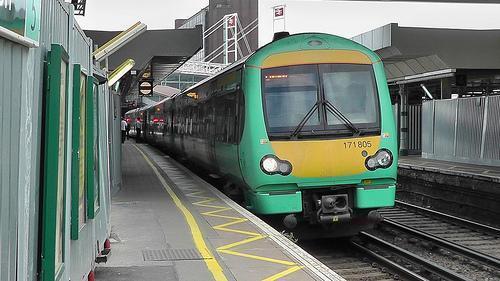How many sets of tracks are there?
Give a very brief answer. 2. 